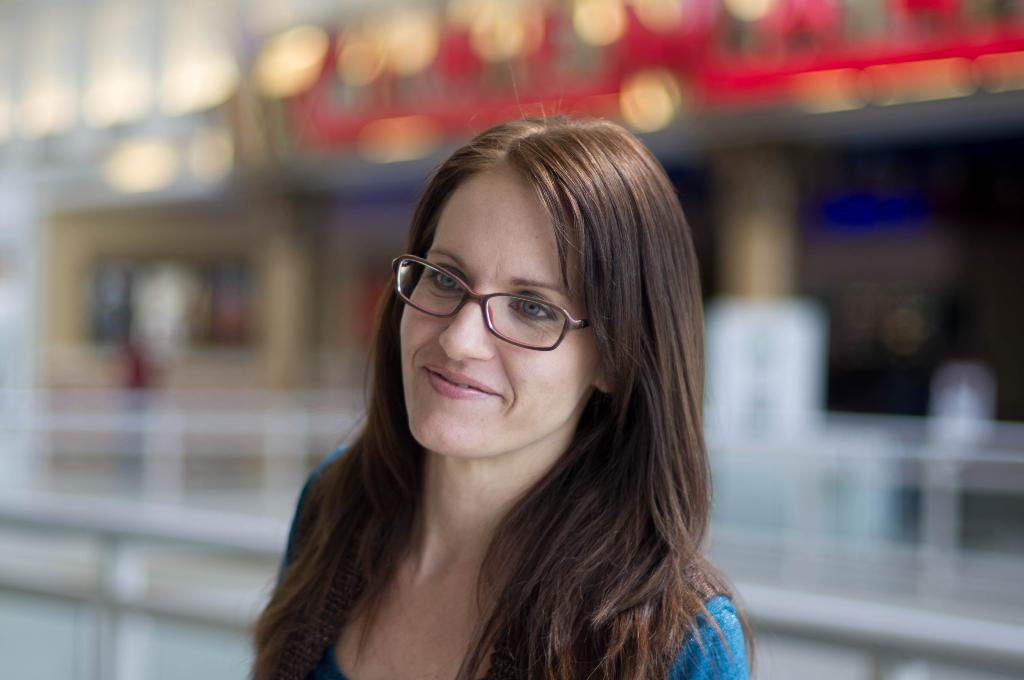Who is the main subject in the image? There is a lady in the image. What accessory is the lady wearing? The lady is wearing glasses. Can you describe the background of the image? The background of the image is blurry. Where is the cart located in the image? There is no cart present in the image. Can you describe the squirrel's behavior in the image? There is no squirrel present in the image. 